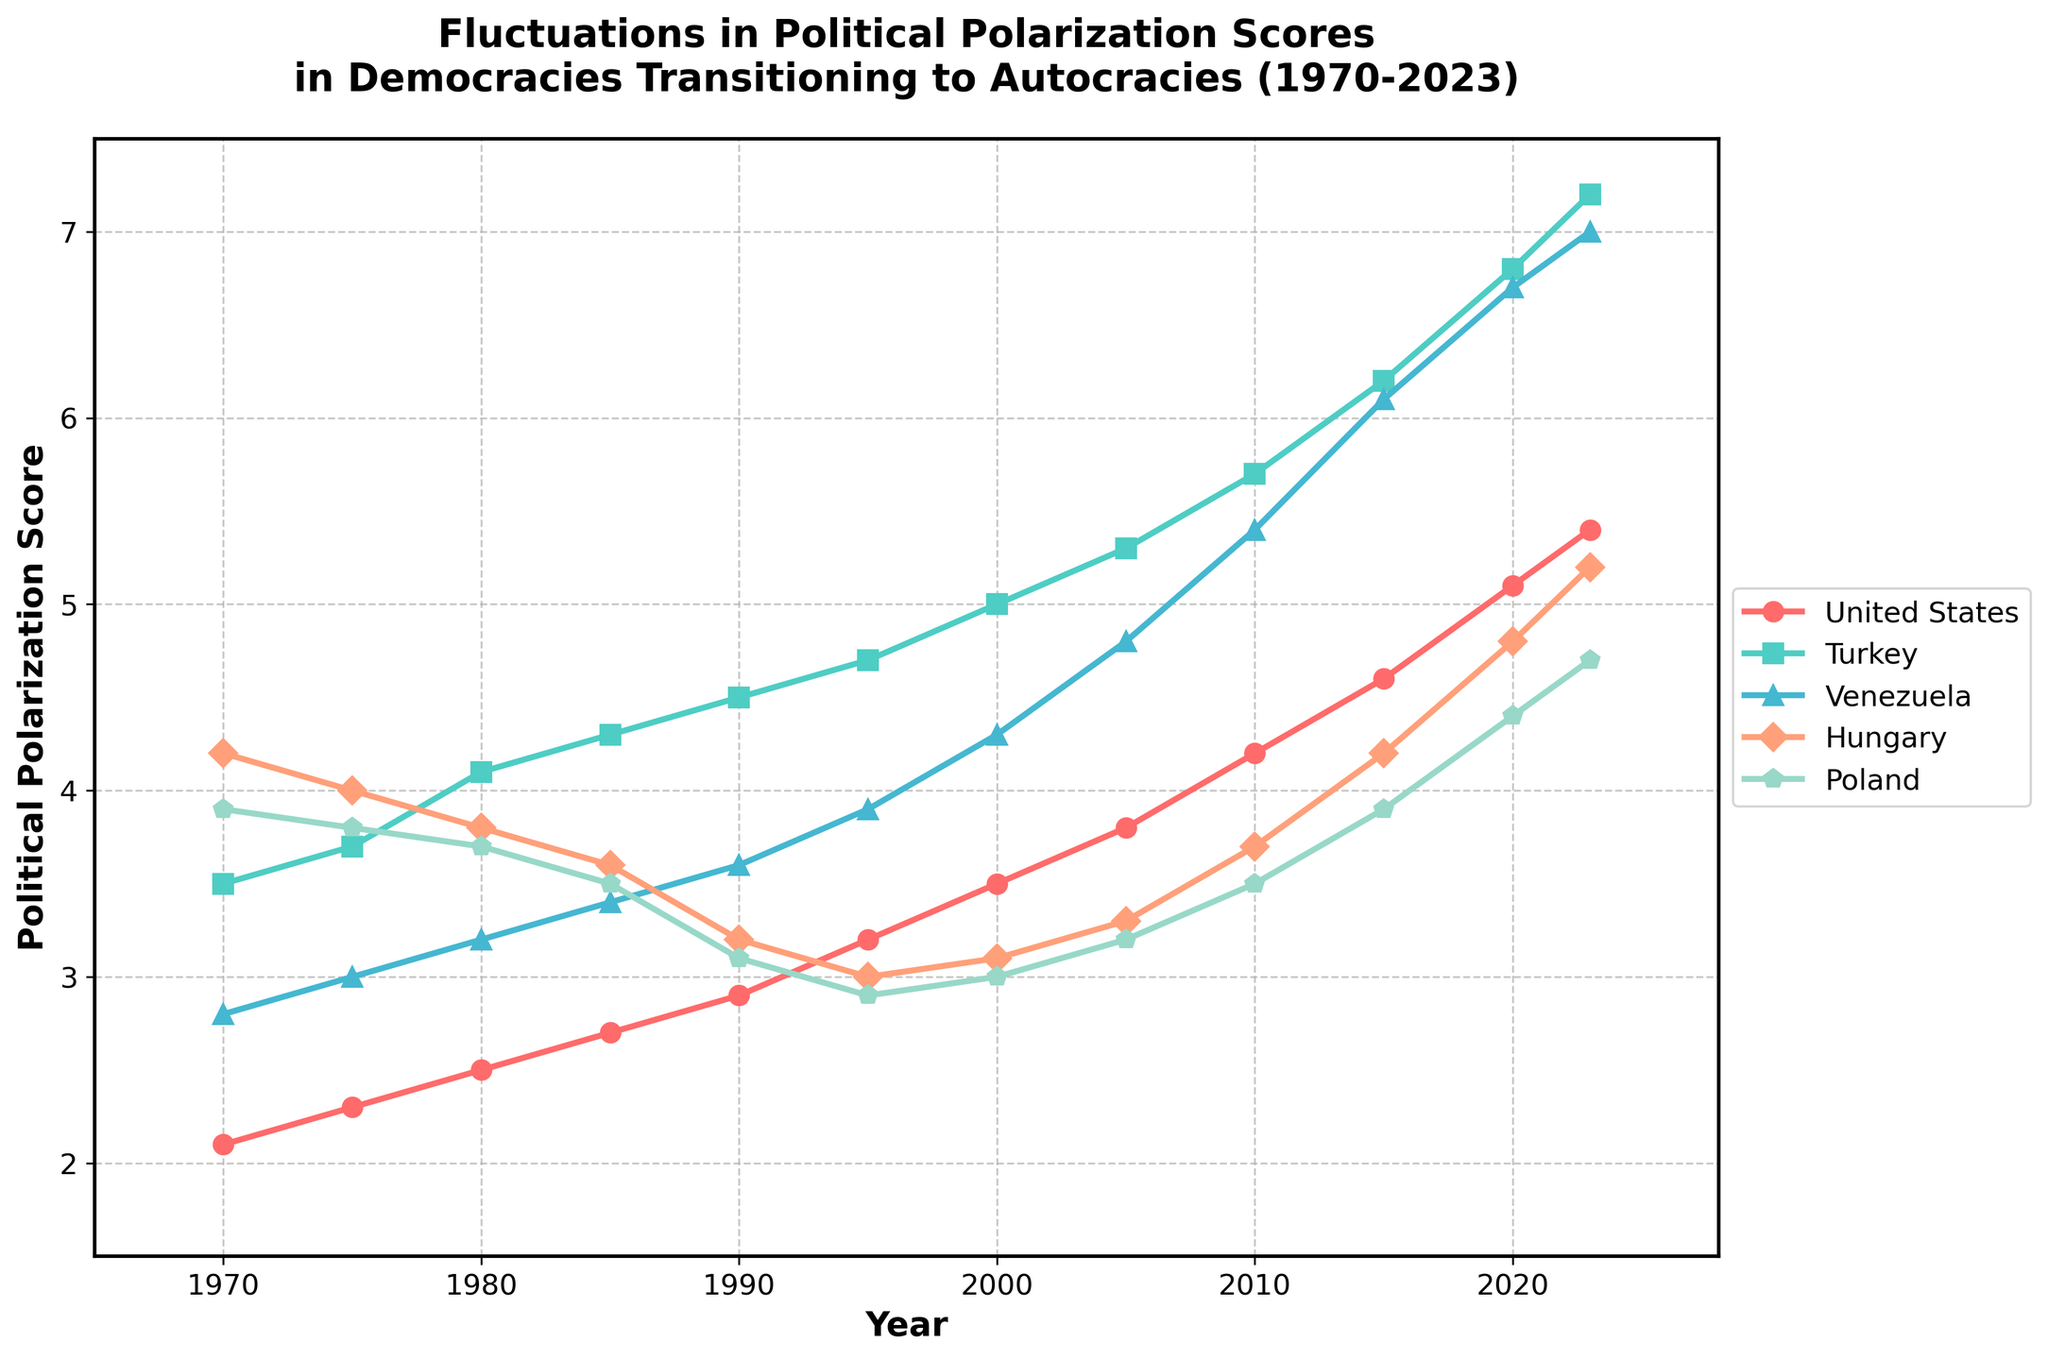What is the overall trend of the political polarization score of Turkey from 1970 to 2023? The plot shows Turkey's scores starting at 3.5 in 1970 and gradually increasing over the years, reaching 7.2 in 2023. This represents a steady upward trend.
Answer: Steady increase Which country had the highest political polarization score in 2023? By observing the plot, Turkey had the highest score at 7.2 in 2023.
Answer: Turkey Between the years 1990 and 2023, which country showed the biggest increase in political polarization score? First, check the scores for each country in 1990 and 2023: United States (2.9 to 5.4), Turkey (4.5 to 7.2), Venezuela (3.6 to 7.0), Hungary (3.2 to 5.2), Poland (3.1 to 4.7). Calculate the increase: US (2.5), Turkey (2.7), Venezuela (3.4), Hungary (2.0), Poland (1.6). Venezuela had the largest increase of 3.4.
Answer: Venezuela Which country's political polarization score was consistently lower throughout the period from 1970 to 2023 compared to the other countries? Observing the plot, Hungary's and Poland's scores are generally lower than those of the United States, Turkey, and Venezuela. Between Hungary and Poland, Poland consistently has the lowest score over the entire period.
Answer: Poland What is the average political polarization score for the United States between 1970 and 2023? Identify the scores for each year: 2.1, 2.3, 2.5, 2.7, 2.9, 3.2, 3.5, 3.8, 4.2, 4.6, 5.1, 5.4. Calculate the sum (40.3) and then divide by the number of years (12), which is 40.3 / 12.
Answer: 3.36 In what year did Hungary and Poland have the same political polarization score? Observing the plot, in 2000 Hungary and Poland both had a score of 3.1.
Answer: 2000 How does the rate of increase in political polarization from 2010 to 2023 compare between Turkey and Hungary? Look at Turkey's score increase from 5.7 to 7.2 (an increase of 1.5) and Hungary's score increase from 3.7 to 5.2 (an increase of 1.5). The rates of increase are equal over this period.
Answer: Equal During which decade did the United States experience the fastest increase in polarization? Observing the plot, the US score increased by 1.3 from 2010 to 2020 (4.2 to 5.1), which is faster compared to other decades.
Answer: 2010-2020 What is the difference in political polarization scores between Turkey and Venezuela in 2023? In 2023, Turkey has a score of 7.2 while Venezuela has a score of 7.0. The difference is 7.2 - 7.0.
Answer: 0.2 